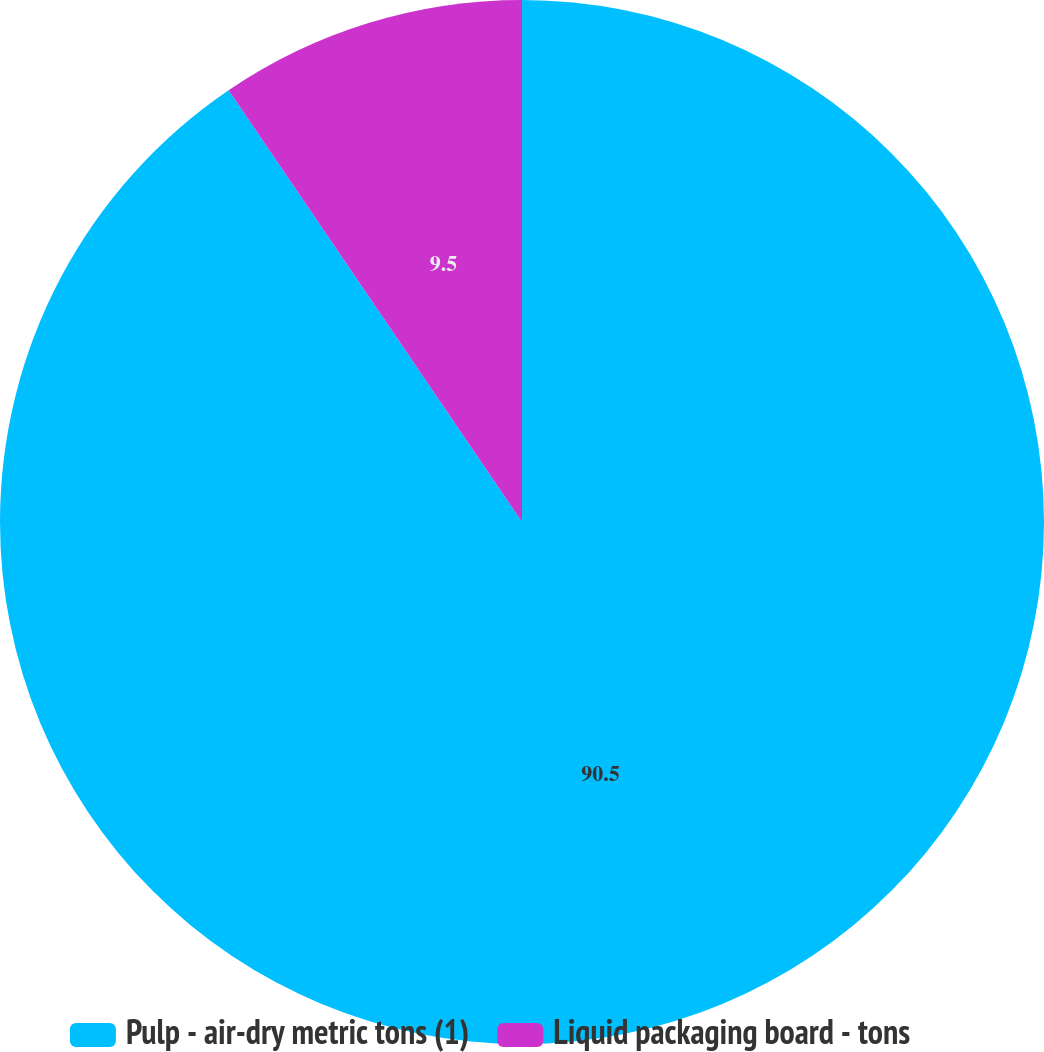Convert chart to OTSL. <chart><loc_0><loc_0><loc_500><loc_500><pie_chart><fcel>Pulp - air-dry metric tons (1)<fcel>Liquid packaging board - tons<nl><fcel>90.5%<fcel>9.5%<nl></chart> 